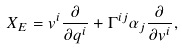<formula> <loc_0><loc_0><loc_500><loc_500>X _ { E } = v ^ { i } \frac { \partial } { \partial q ^ { i } } + \Gamma ^ { i j } \alpha _ { j } \frac { \partial } { \partial v ^ { i } } ,</formula> 